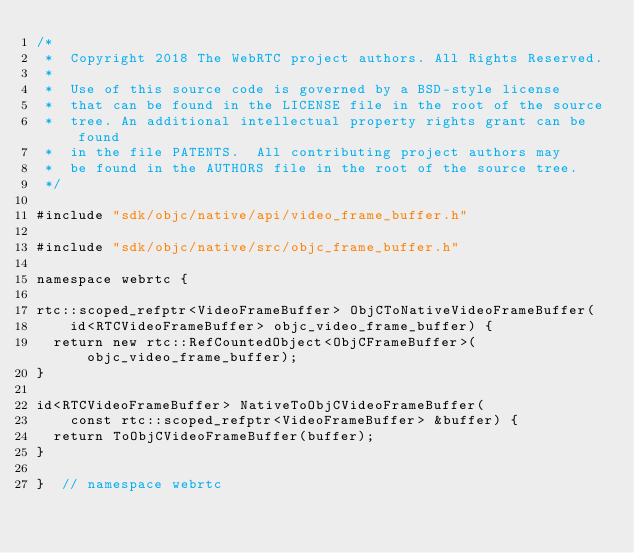<code> <loc_0><loc_0><loc_500><loc_500><_ObjectiveC_>/*
 *  Copyright 2018 The WebRTC project authors. All Rights Reserved.
 *
 *  Use of this source code is governed by a BSD-style license
 *  that can be found in the LICENSE file in the root of the source
 *  tree. An additional intellectual property rights grant can be found
 *  in the file PATENTS.  All contributing project authors may
 *  be found in the AUTHORS file in the root of the source tree.
 */

#include "sdk/objc/native/api/video_frame_buffer.h"

#include "sdk/objc/native/src/objc_frame_buffer.h"

namespace webrtc {

rtc::scoped_refptr<VideoFrameBuffer> ObjCToNativeVideoFrameBuffer(
    id<RTCVideoFrameBuffer> objc_video_frame_buffer) {
  return new rtc::RefCountedObject<ObjCFrameBuffer>(objc_video_frame_buffer);
}

id<RTCVideoFrameBuffer> NativeToObjCVideoFrameBuffer(
    const rtc::scoped_refptr<VideoFrameBuffer> &buffer) {
  return ToObjCVideoFrameBuffer(buffer);
}

}  // namespace webrtc
</code> 